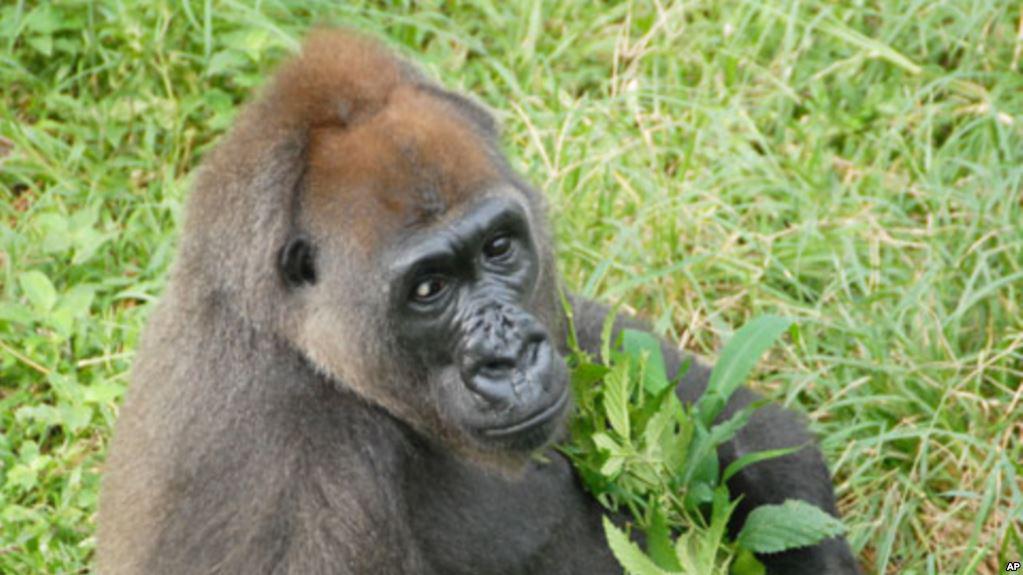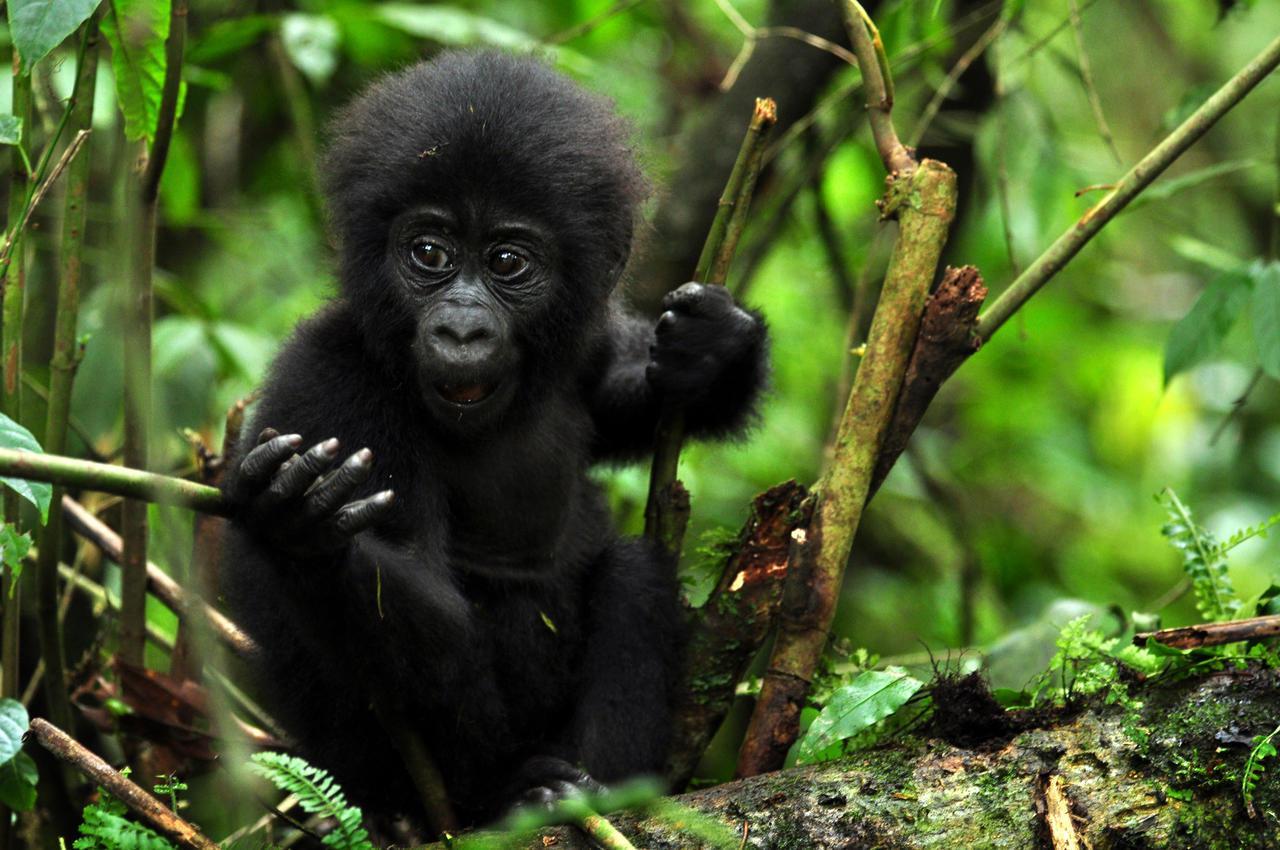The first image is the image on the left, the second image is the image on the right. Given the left and right images, does the statement "The primate in the image on the left is an adult, and there is at least one baby primate in the image on the right." hold true? Answer yes or no. Yes. The first image is the image on the left, the second image is the image on the right. Examine the images to the left and right. Is the description "Each image contains only one gorilla, and one image features an adult gorilla sitting with its body turned rightward and its head somewhat turned to look forward over its shoulder." accurate? Answer yes or no. Yes. 